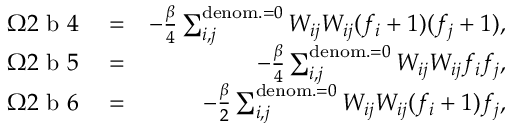<formula> <loc_0><loc_0><loc_500><loc_500>\begin{array} { r l r } { \Omega 2 b 4 } & = } & { - \frac { \beta } { 4 } \sum _ { i , j } ^ { d e n o m . = 0 } { W _ { i j } W _ { i j } } ( f _ { i } + 1 ) ( f _ { j } + 1 ) , } \\ { \Omega 2 b 5 } & = } & { - \frac { \beta } { 4 } \sum _ { i , j } ^ { d e n o m . = 0 } { W _ { i j } W _ { i j } } f _ { i } f _ { j } , } \\ { \Omega 2 b 6 } & = } & { - \frac { \beta } { 2 } \sum _ { i , j } ^ { d e n o m . = 0 } { W _ { i j } W _ { i j } } ( f _ { i } + 1 ) f _ { j } , } \end{array}</formula> 